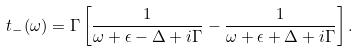<formula> <loc_0><loc_0><loc_500><loc_500>t _ { - } ( \omega ) = \Gamma \left [ \frac { 1 } { \omega + { \epsilon } - \Delta + i \Gamma } - \frac { 1 } { \omega + { \epsilon } + \Delta + i \Gamma } \right ] .</formula> 